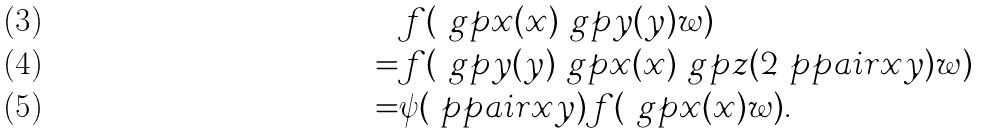<formula> <loc_0><loc_0><loc_500><loc_500>& f ( \ g p x ( x ) \ g p y ( y ) w ) \\ = & f ( \ g p y ( y ) \ g p x ( x ) \ g p z ( 2 \ p p a i r { x } { y } ) w ) \\ = & \psi ( \ p p a i r { x } { y } ) f ( \ g p x ( x ) w ) .</formula> 